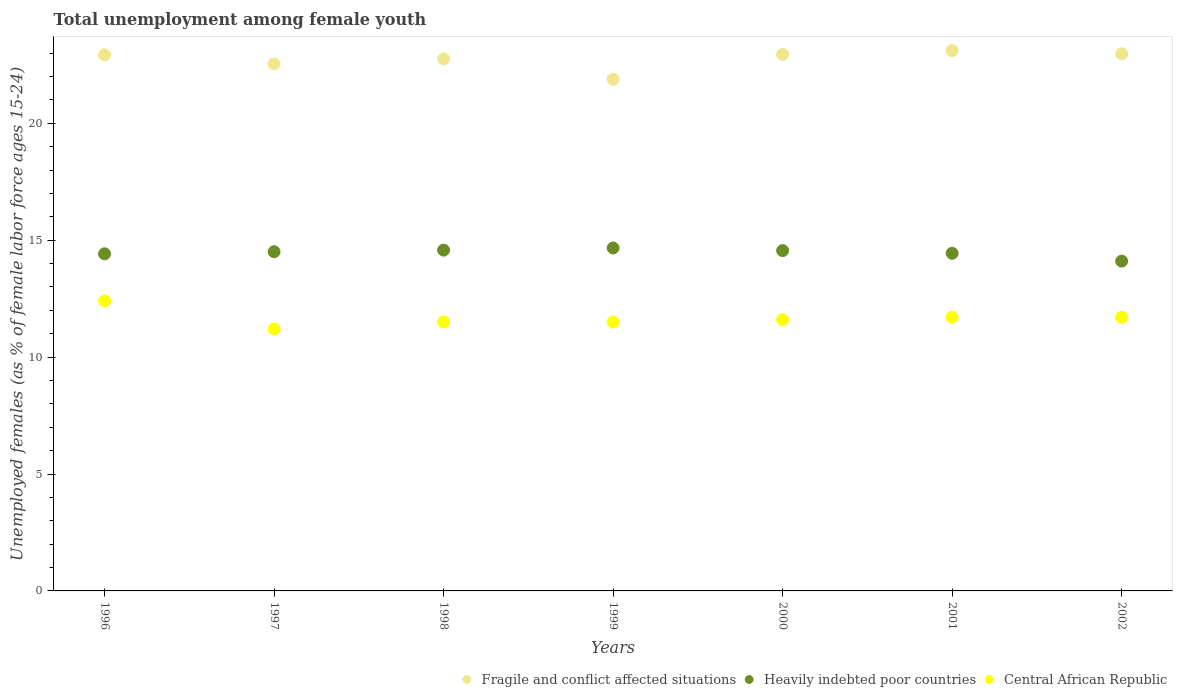How many different coloured dotlines are there?
Provide a short and direct response. 3. What is the percentage of unemployed females in in Central African Republic in 2002?
Your answer should be very brief. 11.7. Across all years, what is the maximum percentage of unemployed females in in Fragile and conflict affected situations?
Provide a short and direct response. 23.11. Across all years, what is the minimum percentage of unemployed females in in Fragile and conflict affected situations?
Provide a succinct answer. 21.88. What is the total percentage of unemployed females in in Central African Republic in the graph?
Your response must be concise. 81.6. What is the difference between the percentage of unemployed females in in Central African Republic in 2000 and that in 2002?
Provide a short and direct response. -0.1. What is the difference between the percentage of unemployed females in in Fragile and conflict affected situations in 1997 and the percentage of unemployed females in in Central African Republic in 1996?
Your answer should be very brief. 10.14. What is the average percentage of unemployed females in in Heavily indebted poor countries per year?
Keep it short and to the point. 14.47. In the year 1999, what is the difference between the percentage of unemployed females in in Fragile and conflict affected situations and percentage of unemployed females in in Central African Republic?
Your answer should be very brief. 10.38. What is the ratio of the percentage of unemployed females in in Central African Republic in 2000 to that in 2001?
Provide a short and direct response. 0.99. Is the percentage of unemployed females in in Central African Republic in 1997 less than that in 2000?
Keep it short and to the point. Yes. Is the difference between the percentage of unemployed females in in Fragile and conflict affected situations in 1998 and 2001 greater than the difference between the percentage of unemployed females in in Central African Republic in 1998 and 2001?
Provide a short and direct response. No. What is the difference between the highest and the second highest percentage of unemployed females in in Fragile and conflict affected situations?
Provide a succinct answer. 0.14. What is the difference between the highest and the lowest percentage of unemployed females in in Central African Republic?
Make the answer very short. 1.2. Is the sum of the percentage of unemployed females in in Heavily indebted poor countries in 1997 and 2001 greater than the maximum percentage of unemployed females in in Central African Republic across all years?
Offer a very short reply. Yes. Does the percentage of unemployed females in in Central African Republic monotonically increase over the years?
Your answer should be very brief. No. Is the percentage of unemployed females in in Central African Republic strictly less than the percentage of unemployed females in in Fragile and conflict affected situations over the years?
Give a very brief answer. Yes. What is the difference between two consecutive major ticks on the Y-axis?
Offer a terse response. 5. Are the values on the major ticks of Y-axis written in scientific E-notation?
Provide a succinct answer. No. Does the graph contain any zero values?
Ensure brevity in your answer.  No. Does the graph contain grids?
Provide a succinct answer. No. How many legend labels are there?
Ensure brevity in your answer.  3. What is the title of the graph?
Provide a succinct answer. Total unemployment among female youth. Does "Heavily indebted poor countries" appear as one of the legend labels in the graph?
Keep it short and to the point. Yes. What is the label or title of the Y-axis?
Give a very brief answer. Unemployed females (as % of female labor force ages 15-24). What is the Unemployed females (as % of female labor force ages 15-24) in Fragile and conflict affected situations in 1996?
Keep it short and to the point. 22.92. What is the Unemployed females (as % of female labor force ages 15-24) of Heavily indebted poor countries in 1996?
Your answer should be very brief. 14.42. What is the Unemployed females (as % of female labor force ages 15-24) of Central African Republic in 1996?
Offer a terse response. 12.4. What is the Unemployed females (as % of female labor force ages 15-24) in Fragile and conflict affected situations in 1997?
Offer a terse response. 22.54. What is the Unemployed females (as % of female labor force ages 15-24) of Heavily indebted poor countries in 1997?
Offer a terse response. 14.51. What is the Unemployed females (as % of female labor force ages 15-24) of Central African Republic in 1997?
Offer a terse response. 11.2. What is the Unemployed females (as % of female labor force ages 15-24) of Fragile and conflict affected situations in 1998?
Your response must be concise. 22.75. What is the Unemployed females (as % of female labor force ages 15-24) of Heavily indebted poor countries in 1998?
Your response must be concise. 14.57. What is the Unemployed females (as % of female labor force ages 15-24) of Fragile and conflict affected situations in 1999?
Make the answer very short. 21.88. What is the Unemployed females (as % of female labor force ages 15-24) of Heavily indebted poor countries in 1999?
Ensure brevity in your answer.  14.67. What is the Unemployed females (as % of female labor force ages 15-24) in Central African Republic in 1999?
Offer a terse response. 11.5. What is the Unemployed females (as % of female labor force ages 15-24) of Fragile and conflict affected situations in 2000?
Provide a short and direct response. 22.95. What is the Unemployed females (as % of female labor force ages 15-24) in Heavily indebted poor countries in 2000?
Provide a succinct answer. 14.55. What is the Unemployed females (as % of female labor force ages 15-24) in Central African Republic in 2000?
Provide a short and direct response. 11.6. What is the Unemployed females (as % of female labor force ages 15-24) in Fragile and conflict affected situations in 2001?
Offer a terse response. 23.11. What is the Unemployed females (as % of female labor force ages 15-24) in Heavily indebted poor countries in 2001?
Offer a terse response. 14.44. What is the Unemployed females (as % of female labor force ages 15-24) of Central African Republic in 2001?
Your answer should be very brief. 11.7. What is the Unemployed females (as % of female labor force ages 15-24) in Fragile and conflict affected situations in 2002?
Provide a short and direct response. 22.97. What is the Unemployed females (as % of female labor force ages 15-24) of Heavily indebted poor countries in 2002?
Offer a very short reply. 14.1. What is the Unemployed females (as % of female labor force ages 15-24) in Central African Republic in 2002?
Provide a succinct answer. 11.7. Across all years, what is the maximum Unemployed females (as % of female labor force ages 15-24) in Fragile and conflict affected situations?
Keep it short and to the point. 23.11. Across all years, what is the maximum Unemployed females (as % of female labor force ages 15-24) of Heavily indebted poor countries?
Offer a terse response. 14.67. Across all years, what is the maximum Unemployed females (as % of female labor force ages 15-24) in Central African Republic?
Make the answer very short. 12.4. Across all years, what is the minimum Unemployed females (as % of female labor force ages 15-24) in Fragile and conflict affected situations?
Offer a very short reply. 21.88. Across all years, what is the minimum Unemployed females (as % of female labor force ages 15-24) in Heavily indebted poor countries?
Ensure brevity in your answer.  14.1. Across all years, what is the minimum Unemployed females (as % of female labor force ages 15-24) in Central African Republic?
Give a very brief answer. 11.2. What is the total Unemployed females (as % of female labor force ages 15-24) in Fragile and conflict affected situations in the graph?
Offer a terse response. 159.13. What is the total Unemployed females (as % of female labor force ages 15-24) in Heavily indebted poor countries in the graph?
Provide a succinct answer. 101.26. What is the total Unemployed females (as % of female labor force ages 15-24) in Central African Republic in the graph?
Offer a terse response. 81.6. What is the difference between the Unemployed females (as % of female labor force ages 15-24) of Fragile and conflict affected situations in 1996 and that in 1997?
Offer a terse response. 0.38. What is the difference between the Unemployed females (as % of female labor force ages 15-24) of Heavily indebted poor countries in 1996 and that in 1997?
Your response must be concise. -0.09. What is the difference between the Unemployed females (as % of female labor force ages 15-24) in Fragile and conflict affected situations in 1996 and that in 1998?
Make the answer very short. 0.17. What is the difference between the Unemployed females (as % of female labor force ages 15-24) in Heavily indebted poor countries in 1996 and that in 1998?
Ensure brevity in your answer.  -0.16. What is the difference between the Unemployed females (as % of female labor force ages 15-24) of Central African Republic in 1996 and that in 1998?
Keep it short and to the point. 0.9. What is the difference between the Unemployed females (as % of female labor force ages 15-24) of Fragile and conflict affected situations in 1996 and that in 1999?
Give a very brief answer. 1.04. What is the difference between the Unemployed females (as % of female labor force ages 15-24) of Heavily indebted poor countries in 1996 and that in 1999?
Ensure brevity in your answer.  -0.25. What is the difference between the Unemployed females (as % of female labor force ages 15-24) of Central African Republic in 1996 and that in 1999?
Your response must be concise. 0.9. What is the difference between the Unemployed females (as % of female labor force ages 15-24) of Fragile and conflict affected situations in 1996 and that in 2000?
Make the answer very short. -0.02. What is the difference between the Unemployed females (as % of female labor force ages 15-24) of Heavily indebted poor countries in 1996 and that in 2000?
Offer a terse response. -0.14. What is the difference between the Unemployed females (as % of female labor force ages 15-24) in Fragile and conflict affected situations in 1996 and that in 2001?
Make the answer very short. -0.19. What is the difference between the Unemployed females (as % of female labor force ages 15-24) of Heavily indebted poor countries in 1996 and that in 2001?
Make the answer very short. -0.02. What is the difference between the Unemployed females (as % of female labor force ages 15-24) in Fragile and conflict affected situations in 1996 and that in 2002?
Offer a very short reply. -0.05. What is the difference between the Unemployed females (as % of female labor force ages 15-24) of Heavily indebted poor countries in 1996 and that in 2002?
Your answer should be very brief. 0.31. What is the difference between the Unemployed females (as % of female labor force ages 15-24) in Fragile and conflict affected situations in 1997 and that in 1998?
Offer a terse response. -0.21. What is the difference between the Unemployed females (as % of female labor force ages 15-24) of Heavily indebted poor countries in 1997 and that in 1998?
Make the answer very short. -0.07. What is the difference between the Unemployed females (as % of female labor force ages 15-24) of Central African Republic in 1997 and that in 1998?
Offer a very short reply. -0.3. What is the difference between the Unemployed females (as % of female labor force ages 15-24) in Fragile and conflict affected situations in 1997 and that in 1999?
Your answer should be very brief. 0.66. What is the difference between the Unemployed females (as % of female labor force ages 15-24) in Heavily indebted poor countries in 1997 and that in 1999?
Make the answer very short. -0.16. What is the difference between the Unemployed females (as % of female labor force ages 15-24) in Central African Republic in 1997 and that in 1999?
Give a very brief answer. -0.3. What is the difference between the Unemployed females (as % of female labor force ages 15-24) in Fragile and conflict affected situations in 1997 and that in 2000?
Offer a terse response. -0.41. What is the difference between the Unemployed females (as % of female labor force ages 15-24) in Heavily indebted poor countries in 1997 and that in 2000?
Your answer should be compact. -0.05. What is the difference between the Unemployed females (as % of female labor force ages 15-24) of Fragile and conflict affected situations in 1997 and that in 2001?
Offer a very short reply. -0.57. What is the difference between the Unemployed females (as % of female labor force ages 15-24) of Heavily indebted poor countries in 1997 and that in 2001?
Provide a succinct answer. 0.07. What is the difference between the Unemployed females (as % of female labor force ages 15-24) in Fragile and conflict affected situations in 1997 and that in 2002?
Ensure brevity in your answer.  -0.43. What is the difference between the Unemployed females (as % of female labor force ages 15-24) in Heavily indebted poor countries in 1997 and that in 2002?
Make the answer very short. 0.4. What is the difference between the Unemployed females (as % of female labor force ages 15-24) in Central African Republic in 1997 and that in 2002?
Offer a terse response. -0.5. What is the difference between the Unemployed females (as % of female labor force ages 15-24) in Fragile and conflict affected situations in 1998 and that in 1999?
Your answer should be compact. 0.87. What is the difference between the Unemployed females (as % of female labor force ages 15-24) in Heavily indebted poor countries in 1998 and that in 1999?
Provide a short and direct response. -0.09. What is the difference between the Unemployed females (as % of female labor force ages 15-24) in Central African Republic in 1998 and that in 1999?
Give a very brief answer. 0. What is the difference between the Unemployed females (as % of female labor force ages 15-24) of Fragile and conflict affected situations in 1998 and that in 2000?
Provide a succinct answer. -0.19. What is the difference between the Unemployed females (as % of female labor force ages 15-24) of Heavily indebted poor countries in 1998 and that in 2000?
Offer a very short reply. 0.02. What is the difference between the Unemployed females (as % of female labor force ages 15-24) in Central African Republic in 1998 and that in 2000?
Your answer should be very brief. -0.1. What is the difference between the Unemployed females (as % of female labor force ages 15-24) in Fragile and conflict affected situations in 1998 and that in 2001?
Provide a short and direct response. -0.36. What is the difference between the Unemployed females (as % of female labor force ages 15-24) in Heavily indebted poor countries in 1998 and that in 2001?
Your response must be concise. 0.13. What is the difference between the Unemployed females (as % of female labor force ages 15-24) in Central African Republic in 1998 and that in 2001?
Your response must be concise. -0.2. What is the difference between the Unemployed females (as % of female labor force ages 15-24) in Fragile and conflict affected situations in 1998 and that in 2002?
Give a very brief answer. -0.22. What is the difference between the Unemployed females (as % of female labor force ages 15-24) in Heavily indebted poor countries in 1998 and that in 2002?
Give a very brief answer. 0.47. What is the difference between the Unemployed females (as % of female labor force ages 15-24) in Central African Republic in 1998 and that in 2002?
Your response must be concise. -0.2. What is the difference between the Unemployed females (as % of female labor force ages 15-24) of Fragile and conflict affected situations in 1999 and that in 2000?
Provide a succinct answer. -1.06. What is the difference between the Unemployed females (as % of female labor force ages 15-24) of Heavily indebted poor countries in 1999 and that in 2000?
Your answer should be compact. 0.11. What is the difference between the Unemployed females (as % of female labor force ages 15-24) in Central African Republic in 1999 and that in 2000?
Provide a succinct answer. -0.1. What is the difference between the Unemployed females (as % of female labor force ages 15-24) of Fragile and conflict affected situations in 1999 and that in 2001?
Give a very brief answer. -1.23. What is the difference between the Unemployed females (as % of female labor force ages 15-24) in Heavily indebted poor countries in 1999 and that in 2001?
Make the answer very short. 0.23. What is the difference between the Unemployed females (as % of female labor force ages 15-24) in Fragile and conflict affected situations in 1999 and that in 2002?
Ensure brevity in your answer.  -1.09. What is the difference between the Unemployed females (as % of female labor force ages 15-24) in Heavily indebted poor countries in 1999 and that in 2002?
Ensure brevity in your answer.  0.56. What is the difference between the Unemployed females (as % of female labor force ages 15-24) of Fragile and conflict affected situations in 2000 and that in 2001?
Offer a very short reply. -0.16. What is the difference between the Unemployed females (as % of female labor force ages 15-24) in Heavily indebted poor countries in 2000 and that in 2001?
Ensure brevity in your answer.  0.12. What is the difference between the Unemployed females (as % of female labor force ages 15-24) in Fragile and conflict affected situations in 2000 and that in 2002?
Give a very brief answer. -0.02. What is the difference between the Unemployed females (as % of female labor force ages 15-24) of Heavily indebted poor countries in 2000 and that in 2002?
Ensure brevity in your answer.  0.45. What is the difference between the Unemployed females (as % of female labor force ages 15-24) in Central African Republic in 2000 and that in 2002?
Offer a terse response. -0.1. What is the difference between the Unemployed females (as % of female labor force ages 15-24) in Fragile and conflict affected situations in 2001 and that in 2002?
Provide a succinct answer. 0.14. What is the difference between the Unemployed females (as % of female labor force ages 15-24) in Heavily indebted poor countries in 2001 and that in 2002?
Provide a short and direct response. 0.33. What is the difference between the Unemployed females (as % of female labor force ages 15-24) of Central African Republic in 2001 and that in 2002?
Your answer should be very brief. 0. What is the difference between the Unemployed females (as % of female labor force ages 15-24) in Fragile and conflict affected situations in 1996 and the Unemployed females (as % of female labor force ages 15-24) in Heavily indebted poor countries in 1997?
Keep it short and to the point. 8.42. What is the difference between the Unemployed females (as % of female labor force ages 15-24) of Fragile and conflict affected situations in 1996 and the Unemployed females (as % of female labor force ages 15-24) of Central African Republic in 1997?
Offer a terse response. 11.72. What is the difference between the Unemployed females (as % of female labor force ages 15-24) in Heavily indebted poor countries in 1996 and the Unemployed females (as % of female labor force ages 15-24) in Central African Republic in 1997?
Your response must be concise. 3.22. What is the difference between the Unemployed females (as % of female labor force ages 15-24) in Fragile and conflict affected situations in 1996 and the Unemployed females (as % of female labor force ages 15-24) in Heavily indebted poor countries in 1998?
Offer a terse response. 8.35. What is the difference between the Unemployed females (as % of female labor force ages 15-24) in Fragile and conflict affected situations in 1996 and the Unemployed females (as % of female labor force ages 15-24) in Central African Republic in 1998?
Ensure brevity in your answer.  11.42. What is the difference between the Unemployed females (as % of female labor force ages 15-24) of Heavily indebted poor countries in 1996 and the Unemployed females (as % of female labor force ages 15-24) of Central African Republic in 1998?
Make the answer very short. 2.92. What is the difference between the Unemployed females (as % of female labor force ages 15-24) in Fragile and conflict affected situations in 1996 and the Unemployed females (as % of female labor force ages 15-24) in Heavily indebted poor countries in 1999?
Make the answer very short. 8.26. What is the difference between the Unemployed females (as % of female labor force ages 15-24) in Fragile and conflict affected situations in 1996 and the Unemployed females (as % of female labor force ages 15-24) in Central African Republic in 1999?
Give a very brief answer. 11.42. What is the difference between the Unemployed females (as % of female labor force ages 15-24) of Heavily indebted poor countries in 1996 and the Unemployed females (as % of female labor force ages 15-24) of Central African Republic in 1999?
Your answer should be compact. 2.92. What is the difference between the Unemployed females (as % of female labor force ages 15-24) of Fragile and conflict affected situations in 1996 and the Unemployed females (as % of female labor force ages 15-24) of Heavily indebted poor countries in 2000?
Your answer should be compact. 8.37. What is the difference between the Unemployed females (as % of female labor force ages 15-24) of Fragile and conflict affected situations in 1996 and the Unemployed females (as % of female labor force ages 15-24) of Central African Republic in 2000?
Provide a succinct answer. 11.32. What is the difference between the Unemployed females (as % of female labor force ages 15-24) in Heavily indebted poor countries in 1996 and the Unemployed females (as % of female labor force ages 15-24) in Central African Republic in 2000?
Your answer should be very brief. 2.82. What is the difference between the Unemployed females (as % of female labor force ages 15-24) of Fragile and conflict affected situations in 1996 and the Unemployed females (as % of female labor force ages 15-24) of Heavily indebted poor countries in 2001?
Keep it short and to the point. 8.49. What is the difference between the Unemployed females (as % of female labor force ages 15-24) in Fragile and conflict affected situations in 1996 and the Unemployed females (as % of female labor force ages 15-24) in Central African Republic in 2001?
Provide a succinct answer. 11.22. What is the difference between the Unemployed females (as % of female labor force ages 15-24) in Heavily indebted poor countries in 1996 and the Unemployed females (as % of female labor force ages 15-24) in Central African Republic in 2001?
Make the answer very short. 2.72. What is the difference between the Unemployed females (as % of female labor force ages 15-24) in Fragile and conflict affected situations in 1996 and the Unemployed females (as % of female labor force ages 15-24) in Heavily indebted poor countries in 2002?
Provide a short and direct response. 8.82. What is the difference between the Unemployed females (as % of female labor force ages 15-24) in Fragile and conflict affected situations in 1996 and the Unemployed females (as % of female labor force ages 15-24) in Central African Republic in 2002?
Provide a short and direct response. 11.22. What is the difference between the Unemployed females (as % of female labor force ages 15-24) of Heavily indebted poor countries in 1996 and the Unemployed females (as % of female labor force ages 15-24) of Central African Republic in 2002?
Make the answer very short. 2.72. What is the difference between the Unemployed females (as % of female labor force ages 15-24) of Fragile and conflict affected situations in 1997 and the Unemployed females (as % of female labor force ages 15-24) of Heavily indebted poor countries in 1998?
Your answer should be compact. 7.97. What is the difference between the Unemployed females (as % of female labor force ages 15-24) of Fragile and conflict affected situations in 1997 and the Unemployed females (as % of female labor force ages 15-24) of Central African Republic in 1998?
Offer a terse response. 11.04. What is the difference between the Unemployed females (as % of female labor force ages 15-24) in Heavily indebted poor countries in 1997 and the Unemployed females (as % of female labor force ages 15-24) in Central African Republic in 1998?
Provide a succinct answer. 3.01. What is the difference between the Unemployed females (as % of female labor force ages 15-24) in Fragile and conflict affected situations in 1997 and the Unemployed females (as % of female labor force ages 15-24) in Heavily indebted poor countries in 1999?
Offer a very short reply. 7.87. What is the difference between the Unemployed females (as % of female labor force ages 15-24) in Fragile and conflict affected situations in 1997 and the Unemployed females (as % of female labor force ages 15-24) in Central African Republic in 1999?
Ensure brevity in your answer.  11.04. What is the difference between the Unemployed females (as % of female labor force ages 15-24) of Heavily indebted poor countries in 1997 and the Unemployed females (as % of female labor force ages 15-24) of Central African Republic in 1999?
Offer a very short reply. 3.01. What is the difference between the Unemployed females (as % of female labor force ages 15-24) in Fragile and conflict affected situations in 1997 and the Unemployed females (as % of female labor force ages 15-24) in Heavily indebted poor countries in 2000?
Your answer should be compact. 7.99. What is the difference between the Unemployed females (as % of female labor force ages 15-24) in Fragile and conflict affected situations in 1997 and the Unemployed females (as % of female labor force ages 15-24) in Central African Republic in 2000?
Offer a very short reply. 10.94. What is the difference between the Unemployed females (as % of female labor force ages 15-24) of Heavily indebted poor countries in 1997 and the Unemployed females (as % of female labor force ages 15-24) of Central African Republic in 2000?
Your answer should be very brief. 2.91. What is the difference between the Unemployed females (as % of female labor force ages 15-24) in Fragile and conflict affected situations in 1997 and the Unemployed females (as % of female labor force ages 15-24) in Heavily indebted poor countries in 2001?
Your answer should be very brief. 8.1. What is the difference between the Unemployed females (as % of female labor force ages 15-24) of Fragile and conflict affected situations in 1997 and the Unemployed females (as % of female labor force ages 15-24) of Central African Republic in 2001?
Provide a succinct answer. 10.84. What is the difference between the Unemployed females (as % of female labor force ages 15-24) in Heavily indebted poor countries in 1997 and the Unemployed females (as % of female labor force ages 15-24) in Central African Republic in 2001?
Offer a very short reply. 2.81. What is the difference between the Unemployed females (as % of female labor force ages 15-24) in Fragile and conflict affected situations in 1997 and the Unemployed females (as % of female labor force ages 15-24) in Heavily indebted poor countries in 2002?
Ensure brevity in your answer.  8.44. What is the difference between the Unemployed females (as % of female labor force ages 15-24) of Fragile and conflict affected situations in 1997 and the Unemployed females (as % of female labor force ages 15-24) of Central African Republic in 2002?
Offer a very short reply. 10.84. What is the difference between the Unemployed females (as % of female labor force ages 15-24) of Heavily indebted poor countries in 1997 and the Unemployed females (as % of female labor force ages 15-24) of Central African Republic in 2002?
Offer a very short reply. 2.81. What is the difference between the Unemployed females (as % of female labor force ages 15-24) of Fragile and conflict affected situations in 1998 and the Unemployed females (as % of female labor force ages 15-24) of Heavily indebted poor countries in 1999?
Ensure brevity in your answer.  8.09. What is the difference between the Unemployed females (as % of female labor force ages 15-24) of Fragile and conflict affected situations in 1998 and the Unemployed females (as % of female labor force ages 15-24) of Central African Republic in 1999?
Offer a very short reply. 11.25. What is the difference between the Unemployed females (as % of female labor force ages 15-24) in Heavily indebted poor countries in 1998 and the Unemployed females (as % of female labor force ages 15-24) in Central African Republic in 1999?
Your answer should be very brief. 3.07. What is the difference between the Unemployed females (as % of female labor force ages 15-24) in Fragile and conflict affected situations in 1998 and the Unemployed females (as % of female labor force ages 15-24) in Heavily indebted poor countries in 2000?
Offer a very short reply. 8.2. What is the difference between the Unemployed females (as % of female labor force ages 15-24) in Fragile and conflict affected situations in 1998 and the Unemployed females (as % of female labor force ages 15-24) in Central African Republic in 2000?
Make the answer very short. 11.15. What is the difference between the Unemployed females (as % of female labor force ages 15-24) of Heavily indebted poor countries in 1998 and the Unemployed females (as % of female labor force ages 15-24) of Central African Republic in 2000?
Your answer should be compact. 2.97. What is the difference between the Unemployed females (as % of female labor force ages 15-24) of Fragile and conflict affected situations in 1998 and the Unemployed females (as % of female labor force ages 15-24) of Heavily indebted poor countries in 2001?
Keep it short and to the point. 8.32. What is the difference between the Unemployed females (as % of female labor force ages 15-24) of Fragile and conflict affected situations in 1998 and the Unemployed females (as % of female labor force ages 15-24) of Central African Republic in 2001?
Keep it short and to the point. 11.05. What is the difference between the Unemployed females (as % of female labor force ages 15-24) in Heavily indebted poor countries in 1998 and the Unemployed females (as % of female labor force ages 15-24) in Central African Republic in 2001?
Give a very brief answer. 2.87. What is the difference between the Unemployed females (as % of female labor force ages 15-24) in Fragile and conflict affected situations in 1998 and the Unemployed females (as % of female labor force ages 15-24) in Heavily indebted poor countries in 2002?
Your response must be concise. 8.65. What is the difference between the Unemployed females (as % of female labor force ages 15-24) of Fragile and conflict affected situations in 1998 and the Unemployed females (as % of female labor force ages 15-24) of Central African Republic in 2002?
Your response must be concise. 11.05. What is the difference between the Unemployed females (as % of female labor force ages 15-24) of Heavily indebted poor countries in 1998 and the Unemployed females (as % of female labor force ages 15-24) of Central African Republic in 2002?
Offer a very short reply. 2.87. What is the difference between the Unemployed females (as % of female labor force ages 15-24) in Fragile and conflict affected situations in 1999 and the Unemployed females (as % of female labor force ages 15-24) in Heavily indebted poor countries in 2000?
Your answer should be very brief. 7.33. What is the difference between the Unemployed females (as % of female labor force ages 15-24) in Fragile and conflict affected situations in 1999 and the Unemployed females (as % of female labor force ages 15-24) in Central African Republic in 2000?
Your answer should be compact. 10.28. What is the difference between the Unemployed females (as % of female labor force ages 15-24) of Heavily indebted poor countries in 1999 and the Unemployed females (as % of female labor force ages 15-24) of Central African Republic in 2000?
Give a very brief answer. 3.07. What is the difference between the Unemployed females (as % of female labor force ages 15-24) in Fragile and conflict affected situations in 1999 and the Unemployed females (as % of female labor force ages 15-24) in Heavily indebted poor countries in 2001?
Your answer should be compact. 7.44. What is the difference between the Unemployed females (as % of female labor force ages 15-24) in Fragile and conflict affected situations in 1999 and the Unemployed females (as % of female labor force ages 15-24) in Central African Republic in 2001?
Provide a succinct answer. 10.18. What is the difference between the Unemployed females (as % of female labor force ages 15-24) of Heavily indebted poor countries in 1999 and the Unemployed females (as % of female labor force ages 15-24) of Central African Republic in 2001?
Offer a very short reply. 2.97. What is the difference between the Unemployed females (as % of female labor force ages 15-24) in Fragile and conflict affected situations in 1999 and the Unemployed females (as % of female labor force ages 15-24) in Heavily indebted poor countries in 2002?
Keep it short and to the point. 7.78. What is the difference between the Unemployed females (as % of female labor force ages 15-24) of Fragile and conflict affected situations in 1999 and the Unemployed females (as % of female labor force ages 15-24) of Central African Republic in 2002?
Provide a short and direct response. 10.18. What is the difference between the Unemployed females (as % of female labor force ages 15-24) in Heavily indebted poor countries in 1999 and the Unemployed females (as % of female labor force ages 15-24) in Central African Republic in 2002?
Make the answer very short. 2.97. What is the difference between the Unemployed females (as % of female labor force ages 15-24) in Fragile and conflict affected situations in 2000 and the Unemployed females (as % of female labor force ages 15-24) in Heavily indebted poor countries in 2001?
Your response must be concise. 8.51. What is the difference between the Unemployed females (as % of female labor force ages 15-24) in Fragile and conflict affected situations in 2000 and the Unemployed females (as % of female labor force ages 15-24) in Central African Republic in 2001?
Offer a very short reply. 11.25. What is the difference between the Unemployed females (as % of female labor force ages 15-24) in Heavily indebted poor countries in 2000 and the Unemployed females (as % of female labor force ages 15-24) in Central African Republic in 2001?
Keep it short and to the point. 2.85. What is the difference between the Unemployed females (as % of female labor force ages 15-24) in Fragile and conflict affected situations in 2000 and the Unemployed females (as % of female labor force ages 15-24) in Heavily indebted poor countries in 2002?
Offer a terse response. 8.84. What is the difference between the Unemployed females (as % of female labor force ages 15-24) of Fragile and conflict affected situations in 2000 and the Unemployed females (as % of female labor force ages 15-24) of Central African Republic in 2002?
Ensure brevity in your answer.  11.25. What is the difference between the Unemployed females (as % of female labor force ages 15-24) of Heavily indebted poor countries in 2000 and the Unemployed females (as % of female labor force ages 15-24) of Central African Republic in 2002?
Ensure brevity in your answer.  2.85. What is the difference between the Unemployed females (as % of female labor force ages 15-24) of Fragile and conflict affected situations in 2001 and the Unemployed females (as % of female labor force ages 15-24) of Heavily indebted poor countries in 2002?
Give a very brief answer. 9.01. What is the difference between the Unemployed females (as % of female labor force ages 15-24) in Fragile and conflict affected situations in 2001 and the Unemployed females (as % of female labor force ages 15-24) in Central African Republic in 2002?
Ensure brevity in your answer.  11.41. What is the difference between the Unemployed females (as % of female labor force ages 15-24) of Heavily indebted poor countries in 2001 and the Unemployed females (as % of female labor force ages 15-24) of Central African Republic in 2002?
Your answer should be very brief. 2.74. What is the average Unemployed females (as % of female labor force ages 15-24) in Fragile and conflict affected situations per year?
Offer a terse response. 22.73. What is the average Unemployed females (as % of female labor force ages 15-24) of Heavily indebted poor countries per year?
Provide a succinct answer. 14.47. What is the average Unemployed females (as % of female labor force ages 15-24) in Central African Republic per year?
Your answer should be compact. 11.66. In the year 1996, what is the difference between the Unemployed females (as % of female labor force ages 15-24) of Fragile and conflict affected situations and Unemployed females (as % of female labor force ages 15-24) of Heavily indebted poor countries?
Your answer should be compact. 8.51. In the year 1996, what is the difference between the Unemployed females (as % of female labor force ages 15-24) in Fragile and conflict affected situations and Unemployed females (as % of female labor force ages 15-24) in Central African Republic?
Keep it short and to the point. 10.52. In the year 1996, what is the difference between the Unemployed females (as % of female labor force ages 15-24) of Heavily indebted poor countries and Unemployed females (as % of female labor force ages 15-24) of Central African Republic?
Your response must be concise. 2.02. In the year 1997, what is the difference between the Unemployed females (as % of female labor force ages 15-24) of Fragile and conflict affected situations and Unemployed females (as % of female labor force ages 15-24) of Heavily indebted poor countries?
Your answer should be very brief. 8.03. In the year 1997, what is the difference between the Unemployed females (as % of female labor force ages 15-24) in Fragile and conflict affected situations and Unemployed females (as % of female labor force ages 15-24) in Central African Republic?
Offer a terse response. 11.34. In the year 1997, what is the difference between the Unemployed females (as % of female labor force ages 15-24) of Heavily indebted poor countries and Unemployed females (as % of female labor force ages 15-24) of Central African Republic?
Give a very brief answer. 3.31. In the year 1998, what is the difference between the Unemployed females (as % of female labor force ages 15-24) of Fragile and conflict affected situations and Unemployed females (as % of female labor force ages 15-24) of Heavily indebted poor countries?
Your answer should be very brief. 8.18. In the year 1998, what is the difference between the Unemployed females (as % of female labor force ages 15-24) of Fragile and conflict affected situations and Unemployed females (as % of female labor force ages 15-24) of Central African Republic?
Ensure brevity in your answer.  11.25. In the year 1998, what is the difference between the Unemployed females (as % of female labor force ages 15-24) in Heavily indebted poor countries and Unemployed females (as % of female labor force ages 15-24) in Central African Republic?
Your answer should be compact. 3.07. In the year 1999, what is the difference between the Unemployed females (as % of female labor force ages 15-24) in Fragile and conflict affected situations and Unemployed females (as % of female labor force ages 15-24) in Heavily indebted poor countries?
Give a very brief answer. 7.22. In the year 1999, what is the difference between the Unemployed females (as % of female labor force ages 15-24) of Fragile and conflict affected situations and Unemployed females (as % of female labor force ages 15-24) of Central African Republic?
Offer a very short reply. 10.38. In the year 1999, what is the difference between the Unemployed females (as % of female labor force ages 15-24) of Heavily indebted poor countries and Unemployed females (as % of female labor force ages 15-24) of Central African Republic?
Give a very brief answer. 3.17. In the year 2000, what is the difference between the Unemployed females (as % of female labor force ages 15-24) in Fragile and conflict affected situations and Unemployed females (as % of female labor force ages 15-24) in Heavily indebted poor countries?
Offer a very short reply. 8.39. In the year 2000, what is the difference between the Unemployed females (as % of female labor force ages 15-24) of Fragile and conflict affected situations and Unemployed females (as % of female labor force ages 15-24) of Central African Republic?
Your response must be concise. 11.35. In the year 2000, what is the difference between the Unemployed females (as % of female labor force ages 15-24) in Heavily indebted poor countries and Unemployed females (as % of female labor force ages 15-24) in Central African Republic?
Keep it short and to the point. 2.95. In the year 2001, what is the difference between the Unemployed females (as % of female labor force ages 15-24) of Fragile and conflict affected situations and Unemployed females (as % of female labor force ages 15-24) of Heavily indebted poor countries?
Your response must be concise. 8.67. In the year 2001, what is the difference between the Unemployed females (as % of female labor force ages 15-24) in Fragile and conflict affected situations and Unemployed females (as % of female labor force ages 15-24) in Central African Republic?
Provide a short and direct response. 11.41. In the year 2001, what is the difference between the Unemployed females (as % of female labor force ages 15-24) in Heavily indebted poor countries and Unemployed females (as % of female labor force ages 15-24) in Central African Republic?
Ensure brevity in your answer.  2.74. In the year 2002, what is the difference between the Unemployed females (as % of female labor force ages 15-24) in Fragile and conflict affected situations and Unemployed females (as % of female labor force ages 15-24) in Heavily indebted poor countries?
Your response must be concise. 8.87. In the year 2002, what is the difference between the Unemployed females (as % of female labor force ages 15-24) of Fragile and conflict affected situations and Unemployed females (as % of female labor force ages 15-24) of Central African Republic?
Give a very brief answer. 11.27. In the year 2002, what is the difference between the Unemployed females (as % of female labor force ages 15-24) in Heavily indebted poor countries and Unemployed females (as % of female labor force ages 15-24) in Central African Republic?
Keep it short and to the point. 2.4. What is the ratio of the Unemployed females (as % of female labor force ages 15-24) in Central African Republic in 1996 to that in 1997?
Keep it short and to the point. 1.11. What is the ratio of the Unemployed females (as % of female labor force ages 15-24) in Fragile and conflict affected situations in 1996 to that in 1998?
Offer a very short reply. 1.01. What is the ratio of the Unemployed females (as % of female labor force ages 15-24) in Heavily indebted poor countries in 1996 to that in 1998?
Provide a short and direct response. 0.99. What is the ratio of the Unemployed females (as % of female labor force ages 15-24) of Central African Republic in 1996 to that in 1998?
Your answer should be compact. 1.08. What is the ratio of the Unemployed females (as % of female labor force ages 15-24) of Fragile and conflict affected situations in 1996 to that in 1999?
Make the answer very short. 1.05. What is the ratio of the Unemployed females (as % of female labor force ages 15-24) in Heavily indebted poor countries in 1996 to that in 1999?
Offer a very short reply. 0.98. What is the ratio of the Unemployed females (as % of female labor force ages 15-24) in Central African Republic in 1996 to that in 1999?
Your answer should be very brief. 1.08. What is the ratio of the Unemployed females (as % of female labor force ages 15-24) of Fragile and conflict affected situations in 1996 to that in 2000?
Keep it short and to the point. 1. What is the ratio of the Unemployed females (as % of female labor force ages 15-24) in Heavily indebted poor countries in 1996 to that in 2000?
Keep it short and to the point. 0.99. What is the ratio of the Unemployed females (as % of female labor force ages 15-24) in Central African Republic in 1996 to that in 2000?
Your answer should be compact. 1.07. What is the ratio of the Unemployed females (as % of female labor force ages 15-24) in Central African Republic in 1996 to that in 2001?
Make the answer very short. 1.06. What is the ratio of the Unemployed females (as % of female labor force ages 15-24) of Heavily indebted poor countries in 1996 to that in 2002?
Offer a very short reply. 1.02. What is the ratio of the Unemployed females (as % of female labor force ages 15-24) in Central African Republic in 1996 to that in 2002?
Keep it short and to the point. 1.06. What is the ratio of the Unemployed females (as % of female labor force ages 15-24) in Fragile and conflict affected situations in 1997 to that in 1998?
Provide a short and direct response. 0.99. What is the ratio of the Unemployed females (as % of female labor force ages 15-24) of Heavily indebted poor countries in 1997 to that in 1998?
Offer a terse response. 1. What is the ratio of the Unemployed females (as % of female labor force ages 15-24) in Central African Republic in 1997 to that in 1998?
Provide a short and direct response. 0.97. What is the ratio of the Unemployed females (as % of female labor force ages 15-24) in Fragile and conflict affected situations in 1997 to that in 1999?
Keep it short and to the point. 1.03. What is the ratio of the Unemployed females (as % of female labor force ages 15-24) in Heavily indebted poor countries in 1997 to that in 1999?
Make the answer very short. 0.99. What is the ratio of the Unemployed females (as % of female labor force ages 15-24) in Central African Republic in 1997 to that in 1999?
Give a very brief answer. 0.97. What is the ratio of the Unemployed females (as % of female labor force ages 15-24) in Fragile and conflict affected situations in 1997 to that in 2000?
Your answer should be compact. 0.98. What is the ratio of the Unemployed females (as % of female labor force ages 15-24) of Central African Republic in 1997 to that in 2000?
Your answer should be compact. 0.97. What is the ratio of the Unemployed females (as % of female labor force ages 15-24) in Fragile and conflict affected situations in 1997 to that in 2001?
Ensure brevity in your answer.  0.98. What is the ratio of the Unemployed females (as % of female labor force ages 15-24) in Central African Republic in 1997 to that in 2001?
Make the answer very short. 0.96. What is the ratio of the Unemployed females (as % of female labor force ages 15-24) of Fragile and conflict affected situations in 1997 to that in 2002?
Make the answer very short. 0.98. What is the ratio of the Unemployed females (as % of female labor force ages 15-24) in Heavily indebted poor countries in 1997 to that in 2002?
Give a very brief answer. 1.03. What is the ratio of the Unemployed females (as % of female labor force ages 15-24) of Central African Republic in 1997 to that in 2002?
Give a very brief answer. 0.96. What is the ratio of the Unemployed females (as % of female labor force ages 15-24) in Fragile and conflict affected situations in 1998 to that in 1999?
Ensure brevity in your answer.  1.04. What is the ratio of the Unemployed females (as % of female labor force ages 15-24) of Heavily indebted poor countries in 1998 to that in 1999?
Provide a short and direct response. 0.99. What is the ratio of the Unemployed females (as % of female labor force ages 15-24) of Fragile and conflict affected situations in 1998 to that in 2001?
Keep it short and to the point. 0.98. What is the ratio of the Unemployed females (as % of female labor force ages 15-24) of Heavily indebted poor countries in 1998 to that in 2001?
Your answer should be very brief. 1.01. What is the ratio of the Unemployed females (as % of female labor force ages 15-24) in Central African Republic in 1998 to that in 2001?
Ensure brevity in your answer.  0.98. What is the ratio of the Unemployed females (as % of female labor force ages 15-24) in Fragile and conflict affected situations in 1998 to that in 2002?
Keep it short and to the point. 0.99. What is the ratio of the Unemployed females (as % of female labor force ages 15-24) in Heavily indebted poor countries in 1998 to that in 2002?
Provide a short and direct response. 1.03. What is the ratio of the Unemployed females (as % of female labor force ages 15-24) in Central African Republic in 1998 to that in 2002?
Ensure brevity in your answer.  0.98. What is the ratio of the Unemployed females (as % of female labor force ages 15-24) in Fragile and conflict affected situations in 1999 to that in 2000?
Offer a very short reply. 0.95. What is the ratio of the Unemployed females (as % of female labor force ages 15-24) in Heavily indebted poor countries in 1999 to that in 2000?
Provide a short and direct response. 1.01. What is the ratio of the Unemployed females (as % of female labor force ages 15-24) in Central African Republic in 1999 to that in 2000?
Provide a short and direct response. 0.99. What is the ratio of the Unemployed females (as % of female labor force ages 15-24) of Fragile and conflict affected situations in 1999 to that in 2001?
Keep it short and to the point. 0.95. What is the ratio of the Unemployed females (as % of female labor force ages 15-24) in Heavily indebted poor countries in 1999 to that in 2001?
Your answer should be very brief. 1.02. What is the ratio of the Unemployed females (as % of female labor force ages 15-24) of Central African Republic in 1999 to that in 2001?
Give a very brief answer. 0.98. What is the ratio of the Unemployed females (as % of female labor force ages 15-24) in Fragile and conflict affected situations in 1999 to that in 2002?
Your response must be concise. 0.95. What is the ratio of the Unemployed females (as % of female labor force ages 15-24) of Heavily indebted poor countries in 1999 to that in 2002?
Give a very brief answer. 1.04. What is the ratio of the Unemployed females (as % of female labor force ages 15-24) of Central African Republic in 1999 to that in 2002?
Provide a succinct answer. 0.98. What is the ratio of the Unemployed females (as % of female labor force ages 15-24) of Heavily indebted poor countries in 2000 to that in 2001?
Your answer should be very brief. 1.01. What is the ratio of the Unemployed females (as % of female labor force ages 15-24) in Central African Republic in 2000 to that in 2001?
Offer a very short reply. 0.99. What is the ratio of the Unemployed females (as % of female labor force ages 15-24) in Heavily indebted poor countries in 2000 to that in 2002?
Offer a terse response. 1.03. What is the ratio of the Unemployed females (as % of female labor force ages 15-24) in Heavily indebted poor countries in 2001 to that in 2002?
Keep it short and to the point. 1.02. What is the difference between the highest and the second highest Unemployed females (as % of female labor force ages 15-24) in Fragile and conflict affected situations?
Give a very brief answer. 0.14. What is the difference between the highest and the second highest Unemployed females (as % of female labor force ages 15-24) of Heavily indebted poor countries?
Ensure brevity in your answer.  0.09. What is the difference between the highest and the lowest Unemployed females (as % of female labor force ages 15-24) of Fragile and conflict affected situations?
Make the answer very short. 1.23. What is the difference between the highest and the lowest Unemployed females (as % of female labor force ages 15-24) of Heavily indebted poor countries?
Ensure brevity in your answer.  0.56. 